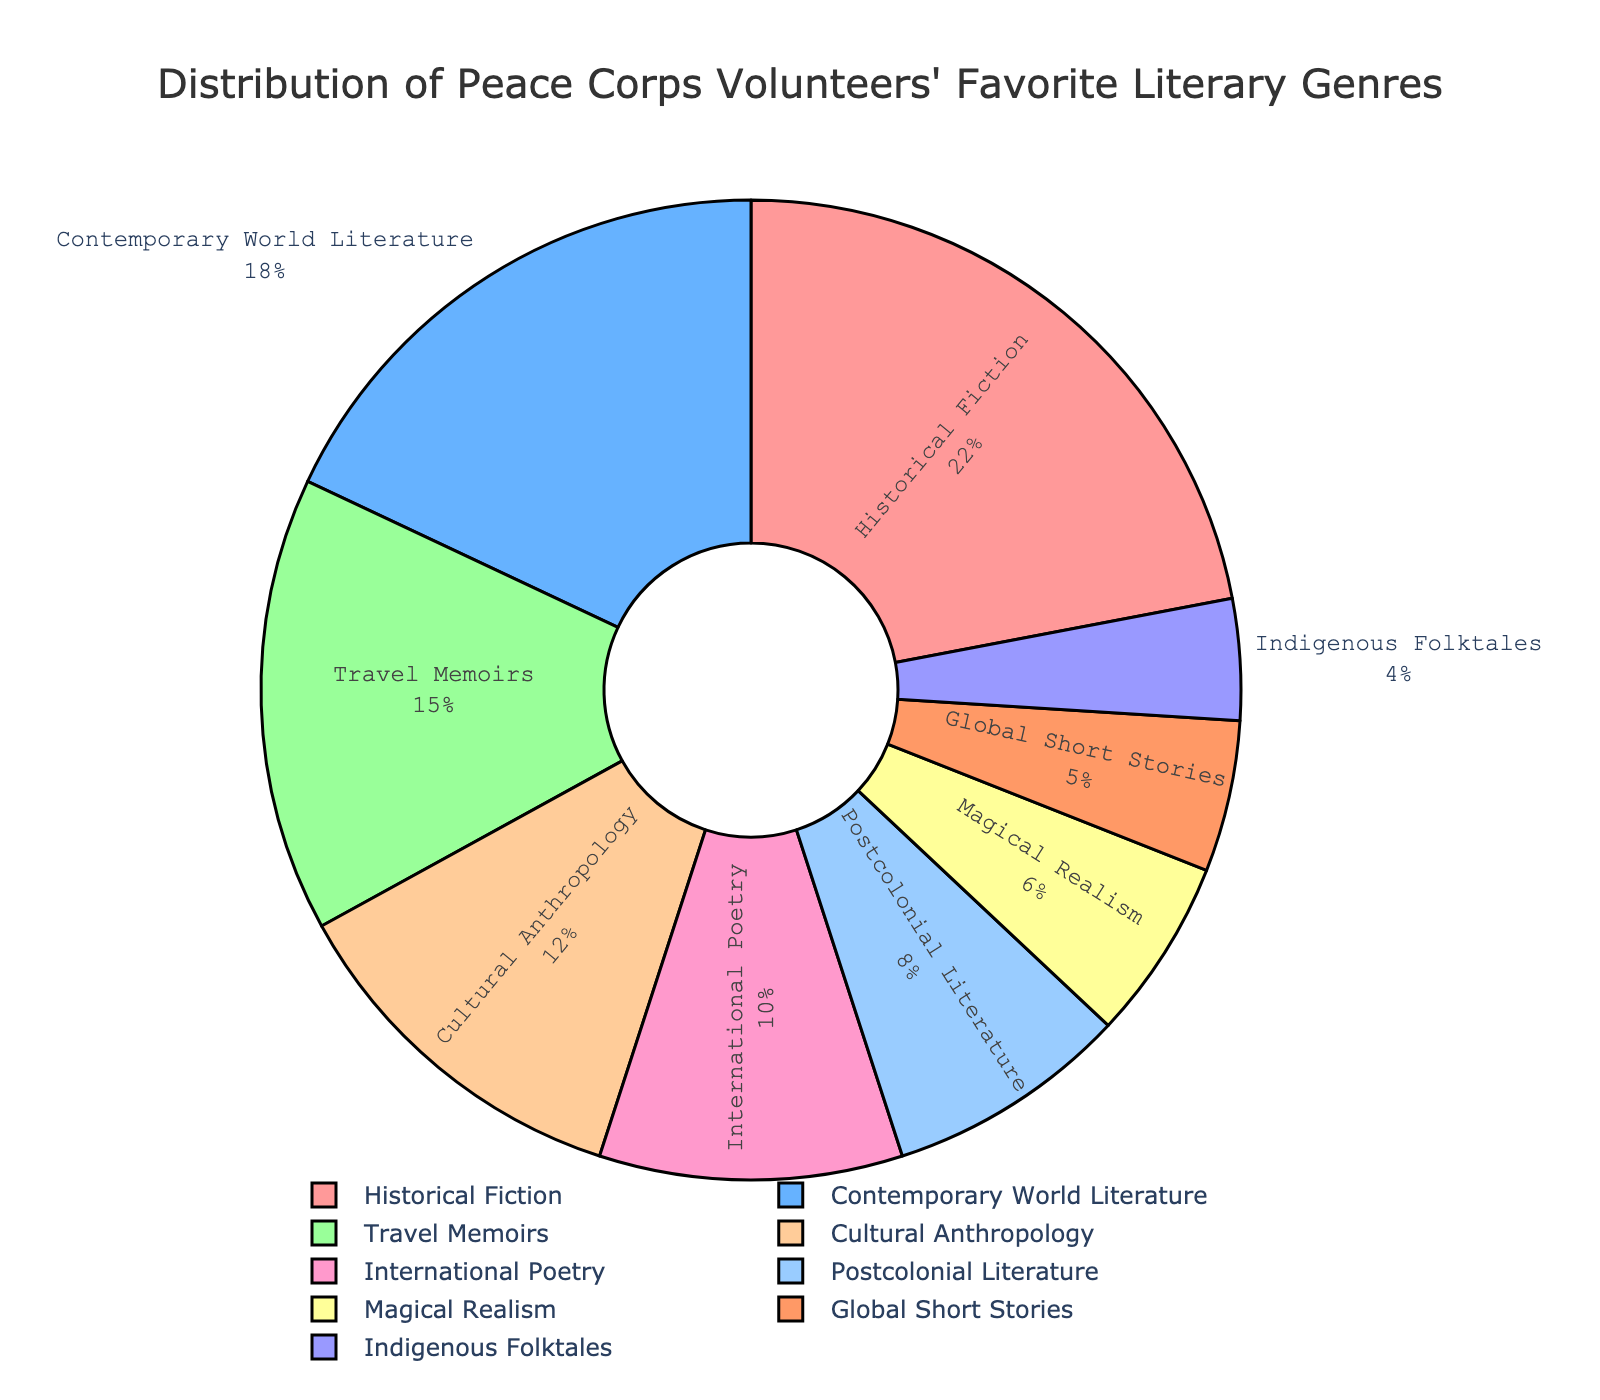Which genre is preferred by the largest percentage of Peace Corps volunteers? The largest segment in the pie chart is labeled "Historical Fiction" with 22%.
Answer: Historical Fiction What is the least favored literary genre among Peace Corps volunteers? The smallest segment in the pie chart is labeled "Indigenous Folktales" with 4%.
Answer: Indigenous Folktales How many genres have a preference percentage of 10% or higher? The genres with preference percentages of 10% or higher are "Historical Fiction" (22%), "Contemporary World Literature" (18%), "Travel Memoirs" (15%), and "Cultural Anthropology" (12%). There are 4 such genres.
Answer: 4 Which genre has a preference percentage closest to the average preference percentage of all genres? To find the average preference percentage, sum up all percentages (22+18+15+12+10+8+6+5+4)=100 and divide by 9 genres, giving an average of approximately 11.1%. The genre closest to this value is "Cultural Anthropology" with 12%.
Answer: Cultural Anthropology Is the combined preference for "Travel Memoirs" and "Postcolonial Literature" greater than for "Historical Fiction"? "Travel Memoirs" has 15% and "Postcolonial Literature" has 8%. Their combined preference is 15% + 8% = 23%, which is greater than 22% for "Historical Fiction".
Answer: Yes Which genre would complete the top three most favored genres among Peace Corps volunteers? The top three genres are the ones with the highest percentages: "Historical Fiction" (22%), "Contemporary World Literature" (18%), and "Travel Memoirs" (15%).
Answer: Travel Memoirs What percentage of volunteers prefer genres categorized as either prose ("Historical Fiction", "Travel Memoirs", "Contemporary World Literature", "Global Short Stories")? Adding the percentages for those prose genres: 22% (Historical Fiction) + 15% (Travel Memoirs) + 18% (Contemporary World Literature) + 5% (Global Short Stories) = 60%.
Answer: 60% How much more popular is "Magical Realism" compared to "Indigenous Folktales"? "Magical Realism" has a preference of 6% and "Indigenous Folktales" has 4%, so "Magical Realism" is 6% - 4% = 2% more popular.
Answer: 2% Which genre has a preference percentage that is roughly half of "Cultural Anthropology"? "Cultural Anthropology" has 12%, and roughly half of this is 12% / 2 = 6%. The genre with a 6% preference is "Magical Realism".
Answer: Magical Realism 